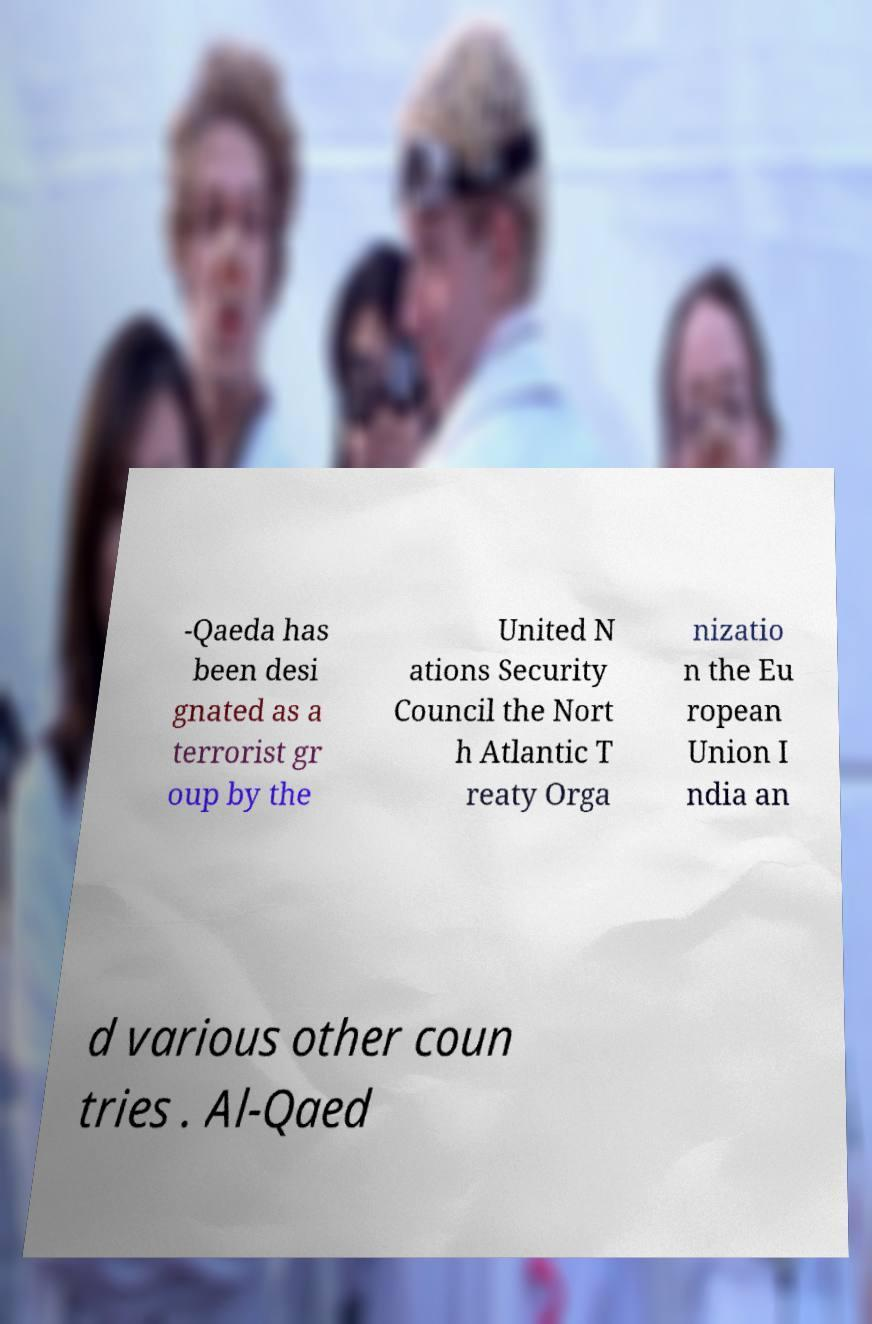Can you accurately transcribe the text from the provided image for me? -Qaeda has been desi gnated as a terrorist gr oup by the United N ations Security Council the Nort h Atlantic T reaty Orga nizatio n the Eu ropean Union I ndia an d various other coun tries . Al-Qaed 